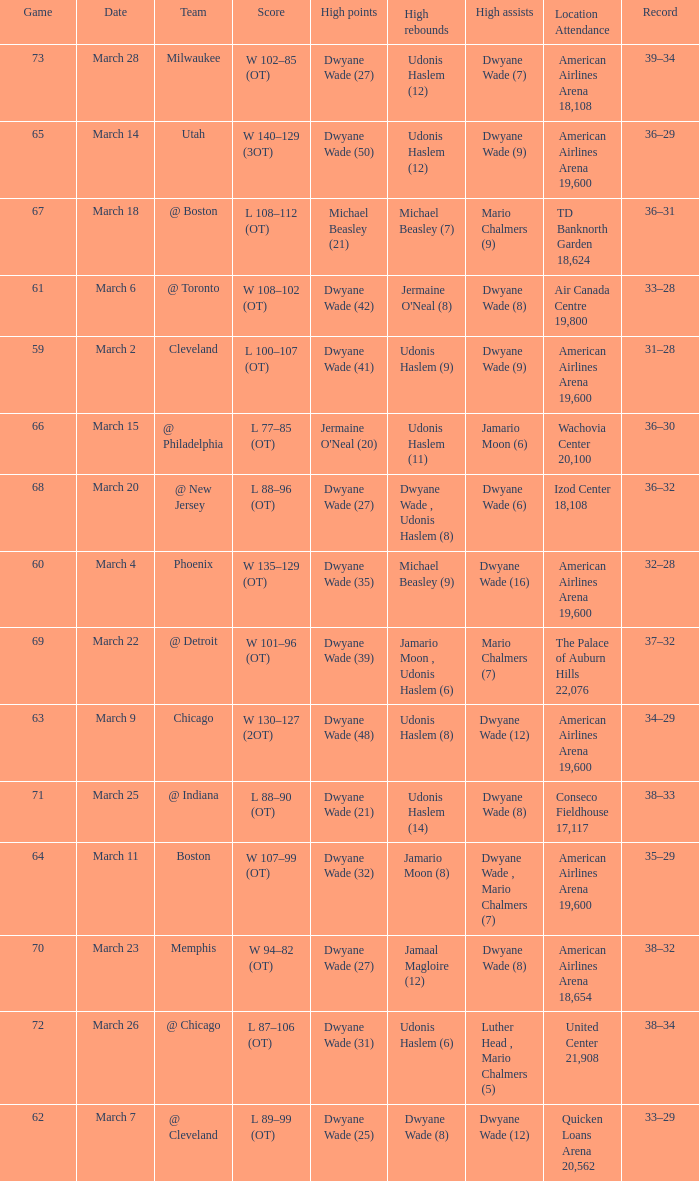Would you mind parsing the complete table? {'header': ['Game', 'Date', 'Team', 'Score', 'High points', 'High rebounds', 'High assists', 'Location Attendance', 'Record'], 'rows': [['73', 'March 28', 'Milwaukee', 'W 102–85 (OT)', 'Dwyane Wade (27)', 'Udonis Haslem (12)', 'Dwyane Wade (7)', 'American Airlines Arena 18,108', '39–34'], ['65', 'March 14', 'Utah', 'W 140–129 (3OT)', 'Dwyane Wade (50)', 'Udonis Haslem (12)', 'Dwyane Wade (9)', 'American Airlines Arena 19,600', '36–29'], ['67', 'March 18', '@ Boston', 'L 108–112 (OT)', 'Michael Beasley (21)', 'Michael Beasley (7)', 'Mario Chalmers (9)', 'TD Banknorth Garden 18,624', '36–31'], ['61', 'March 6', '@ Toronto', 'W 108–102 (OT)', 'Dwyane Wade (42)', "Jermaine O'Neal (8)", 'Dwyane Wade (8)', 'Air Canada Centre 19,800', '33–28'], ['59', 'March 2', 'Cleveland', 'L 100–107 (OT)', 'Dwyane Wade (41)', 'Udonis Haslem (9)', 'Dwyane Wade (9)', 'American Airlines Arena 19,600', '31–28'], ['66', 'March 15', '@ Philadelphia', 'L 77–85 (OT)', "Jermaine O'Neal (20)", 'Udonis Haslem (11)', 'Jamario Moon (6)', 'Wachovia Center 20,100', '36–30'], ['68', 'March 20', '@ New Jersey', 'L 88–96 (OT)', 'Dwyane Wade (27)', 'Dwyane Wade , Udonis Haslem (8)', 'Dwyane Wade (6)', 'Izod Center 18,108', '36–32'], ['60', 'March 4', 'Phoenix', 'W 135–129 (OT)', 'Dwyane Wade (35)', 'Michael Beasley (9)', 'Dwyane Wade (16)', 'American Airlines Arena 19,600', '32–28'], ['69', 'March 22', '@ Detroit', 'W 101–96 (OT)', 'Dwyane Wade (39)', 'Jamario Moon , Udonis Haslem (6)', 'Mario Chalmers (7)', 'The Palace of Auburn Hills 22,076', '37–32'], ['63', 'March 9', 'Chicago', 'W 130–127 (2OT)', 'Dwyane Wade (48)', 'Udonis Haslem (8)', 'Dwyane Wade (12)', 'American Airlines Arena 19,600', '34–29'], ['71', 'March 25', '@ Indiana', 'L 88–90 (OT)', 'Dwyane Wade (21)', 'Udonis Haslem (14)', 'Dwyane Wade (8)', 'Conseco Fieldhouse 17,117', '38–33'], ['64', 'March 11', 'Boston', 'W 107–99 (OT)', 'Dwyane Wade (32)', 'Jamario Moon (8)', 'Dwyane Wade , Mario Chalmers (7)', 'American Airlines Arena 19,600', '35–29'], ['70', 'March 23', 'Memphis', 'W 94–82 (OT)', 'Dwyane Wade (27)', 'Jamaal Magloire (12)', 'Dwyane Wade (8)', 'American Airlines Arena 18,654', '38–32'], ['72', 'March 26', '@ Chicago', 'L 87–106 (OT)', 'Dwyane Wade (31)', 'Udonis Haslem (6)', 'Luther Head , Mario Chalmers (5)', 'United Center 21,908', '38–34'], ['62', 'March 7', '@ Cleveland', 'L 89–99 (OT)', 'Dwyane Wade (25)', 'Dwyane Wade (8)', 'Dwyane Wade (12)', 'Quicken Loans Arena 20,562', '33–29']]} What team(s) did they play on march 9? Chicago. 